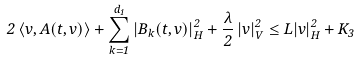<formula> <loc_0><loc_0><loc_500><loc_500>2 \, \langle v , A ( t , v ) \rangle + \sum _ { k = 1 } ^ { d _ { 1 } } | B _ { k } ( t , v ) | ^ { 2 } _ { H } + \frac { \lambda } { 2 } \, | v | ^ { 2 } _ { V } \leq L | v | ^ { 2 } _ { H } + K _ { 3 }</formula> 